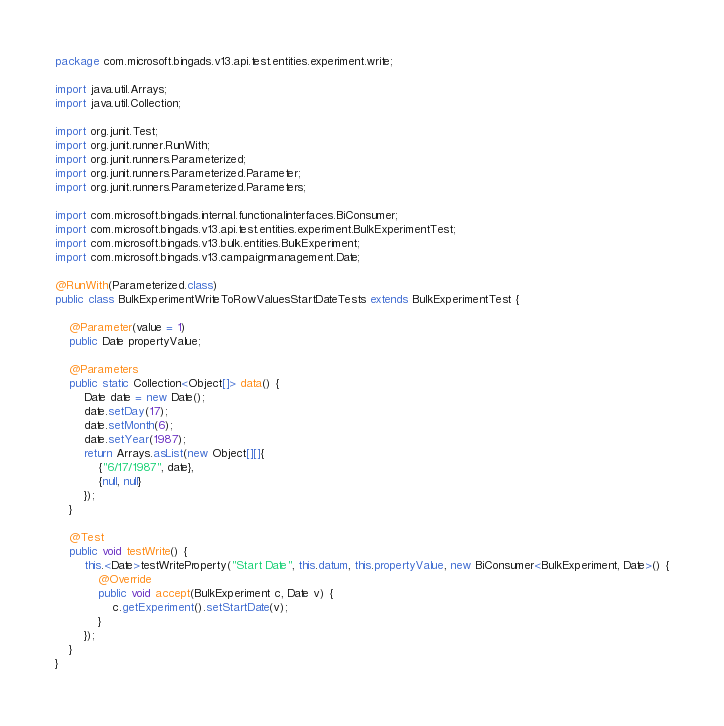Convert code to text. <code><loc_0><loc_0><loc_500><loc_500><_Java_>package com.microsoft.bingads.v13.api.test.entities.experiment.write;

import java.util.Arrays;
import java.util.Collection;

import org.junit.Test;
import org.junit.runner.RunWith;
import org.junit.runners.Parameterized;
import org.junit.runners.Parameterized.Parameter;
import org.junit.runners.Parameterized.Parameters;

import com.microsoft.bingads.internal.functionalinterfaces.BiConsumer;
import com.microsoft.bingads.v13.api.test.entities.experiment.BulkExperimentTest;
import com.microsoft.bingads.v13.bulk.entities.BulkExperiment;
import com.microsoft.bingads.v13.campaignmanagement.Date;

@RunWith(Parameterized.class)
public class BulkExperimentWriteToRowValuesStartDateTests extends BulkExperimentTest {

    @Parameter(value = 1)
    public Date propertyValue;

    @Parameters
    public static Collection<Object[]> data() {
        Date date = new Date();
        date.setDay(17);
        date.setMonth(6);
        date.setYear(1987);
        return Arrays.asList(new Object[][]{
            {"6/17/1987", date},
            {null, null}
        });
    }

    @Test
    public void testWrite() {
        this.<Date>testWriteProperty("Start Date", this.datum, this.propertyValue, new BiConsumer<BulkExperiment, Date>() {
            @Override
            public void accept(BulkExperiment c, Date v) {
                c.getExperiment().setStartDate(v);
            }
        });
    }
}
</code> 